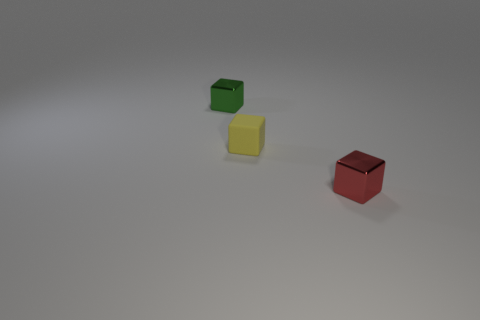Are there any other things that have the same material as the tiny yellow cube?
Offer a very short reply. No. What is the size of the other cube that is made of the same material as the tiny green cube?
Your answer should be compact. Small. Is there another matte block that has the same color as the matte block?
Your response must be concise. No. How many things are either small red objects or tiny shiny things that are to the left of the yellow matte object?
Provide a short and direct response. 2. Is the number of blocks greater than the number of gray spheres?
Offer a very short reply. Yes. Is there a small red cube that has the same material as the small yellow thing?
Offer a very short reply. No. There is a thing that is both left of the red object and in front of the tiny green metallic object; what is its shape?
Offer a very short reply. Cube. What number of other things are there of the same shape as the green object?
Your answer should be very brief. 2. What size is the rubber object?
Offer a terse response. Small. What number of objects are either tiny yellow rubber blocks or small cyan metallic spheres?
Your response must be concise. 1. 